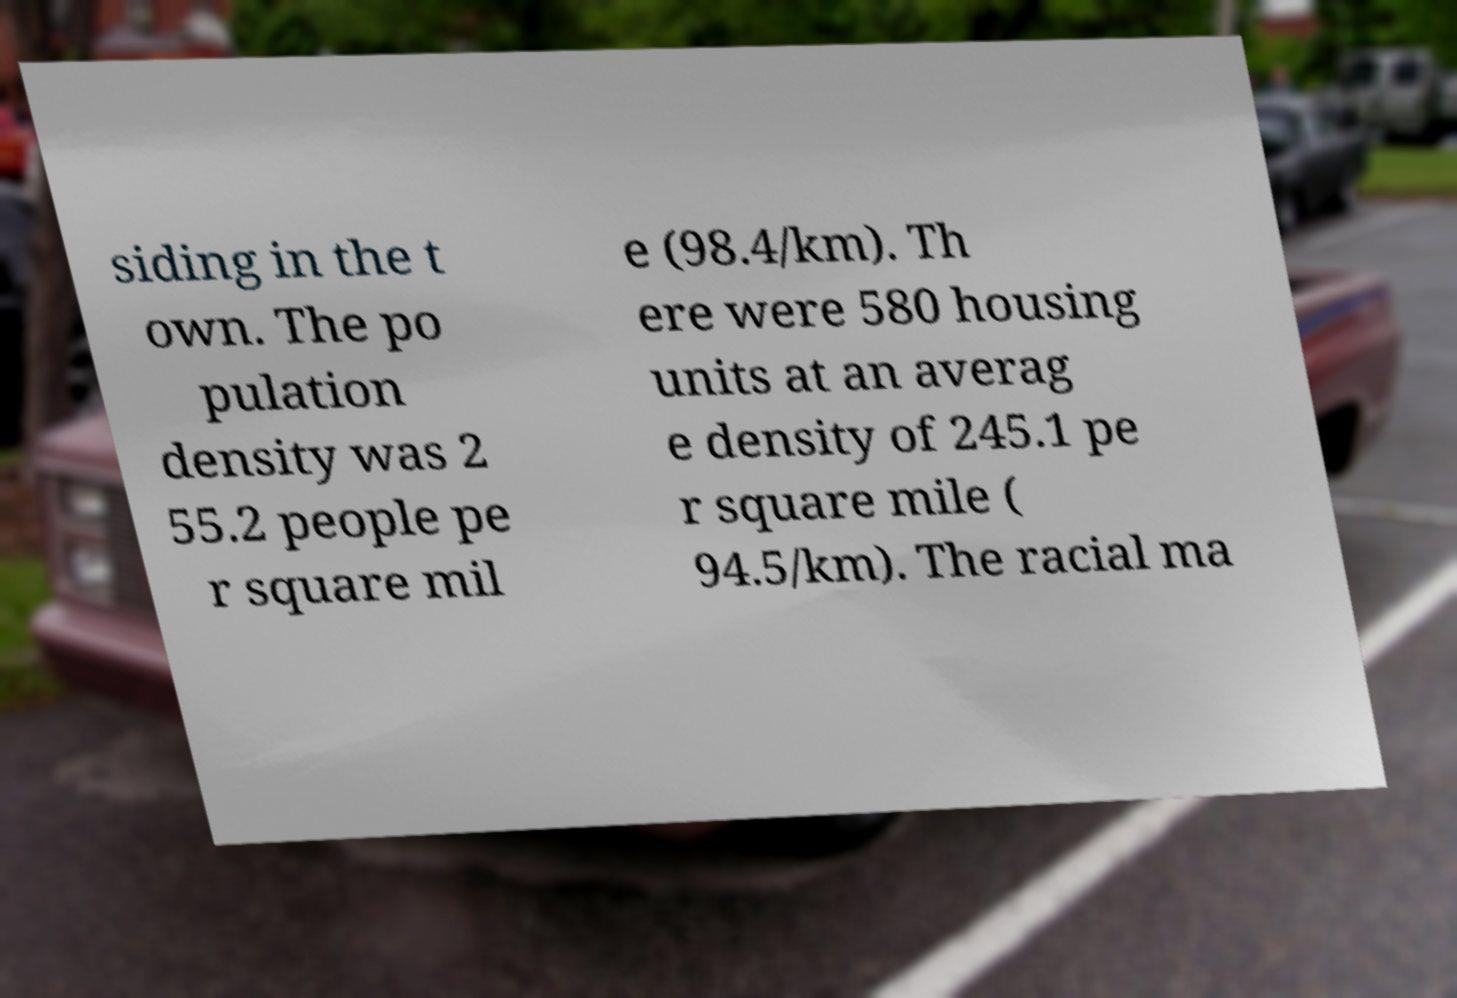What messages or text are displayed in this image? I need them in a readable, typed format. siding in the t own. The po pulation density was 2 55.2 people pe r square mil e (98.4/km). Th ere were 580 housing units at an averag e density of 245.1 pe r square mile ( 94.5/km). The racial ma 